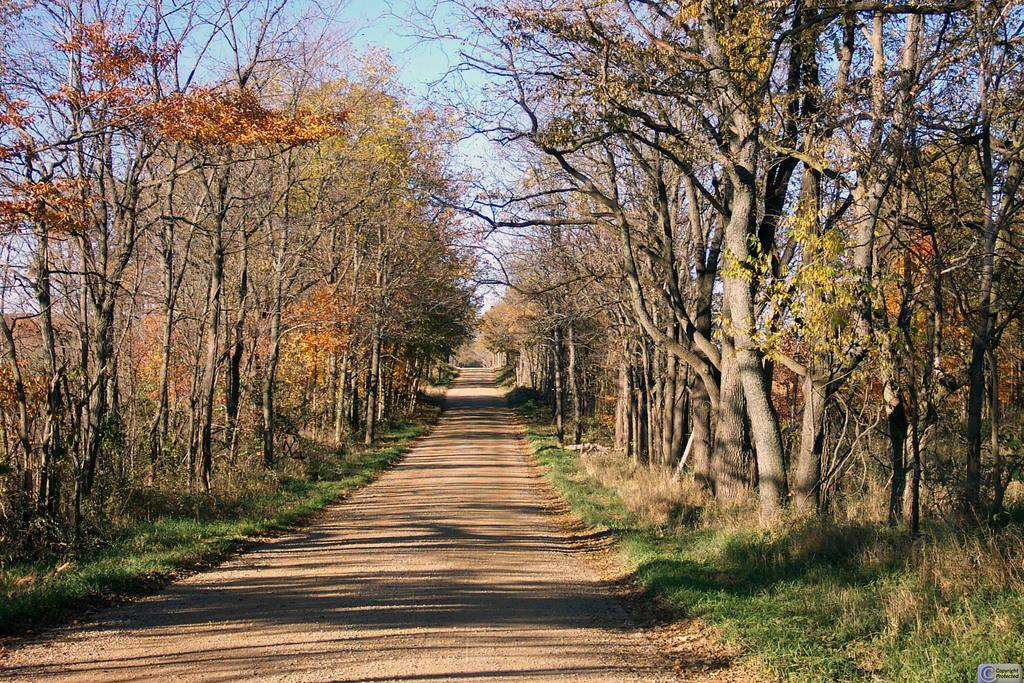What is the main feature of the image? There is a road in the image. What type of vegetation can be seen alongside the road? There is grass visible in the image, and trees are on both sides of the road. What colors are the trees? The trees are green and orange in color. What can be seen in the background of the image? The sky is visible in the background of the image. What invention is being tested on the road in the image? There is no invention being tested on the road in the image. How many trips have been taken on the road in the image? The image does not provide information about the number of trips taken on the road. 